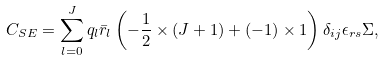Convert formula to latex. <formula><loc_0><loc_0><loc_500><loc_500>& C _ { S E } = \sum _ { l = 0 } ^ { J } q _ { l } \bar { r } _ { l } \left ( - \frac { 1 } { 2 } \times ( J + 1 ) + ( - 1 ) \times 1 \right ) \delta _ { i j } \epsilon _ { r s } \Sigma ,</formula> 